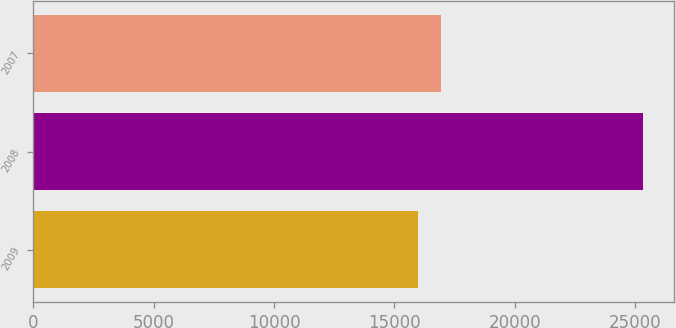Convert chart. <chart><loc_0><loc_0><loc_500><loc_500><bar_chart><fcel>2009<fcel>2008<fcel>2007<nl><fcel>15991<fcel>25335<fcel>16925.4<nl></chart> 